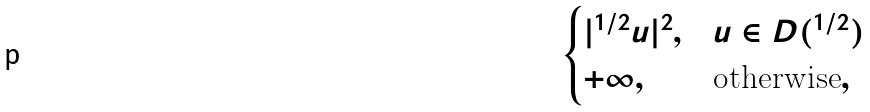<formula> <loc_0><loc_0><loc_500><loc_500>\begin{cases} | \AA ^ { 1 / 2 } u | ^ { 2 } , & u \in D ( \AA ^ { 1 / 2 } ) \\ + \infty , & \text {otherwise} , \end{cases}</formula> 